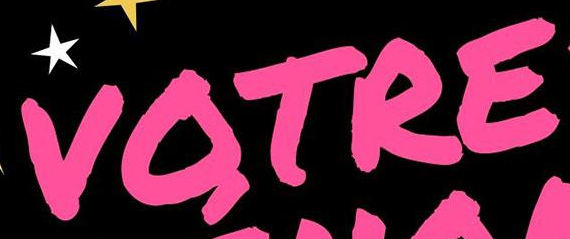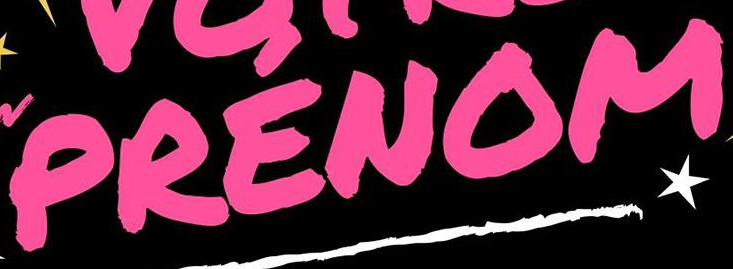What text is displayed in these images sequentially, separated by a semicolon? VOTRE; PRENOM 